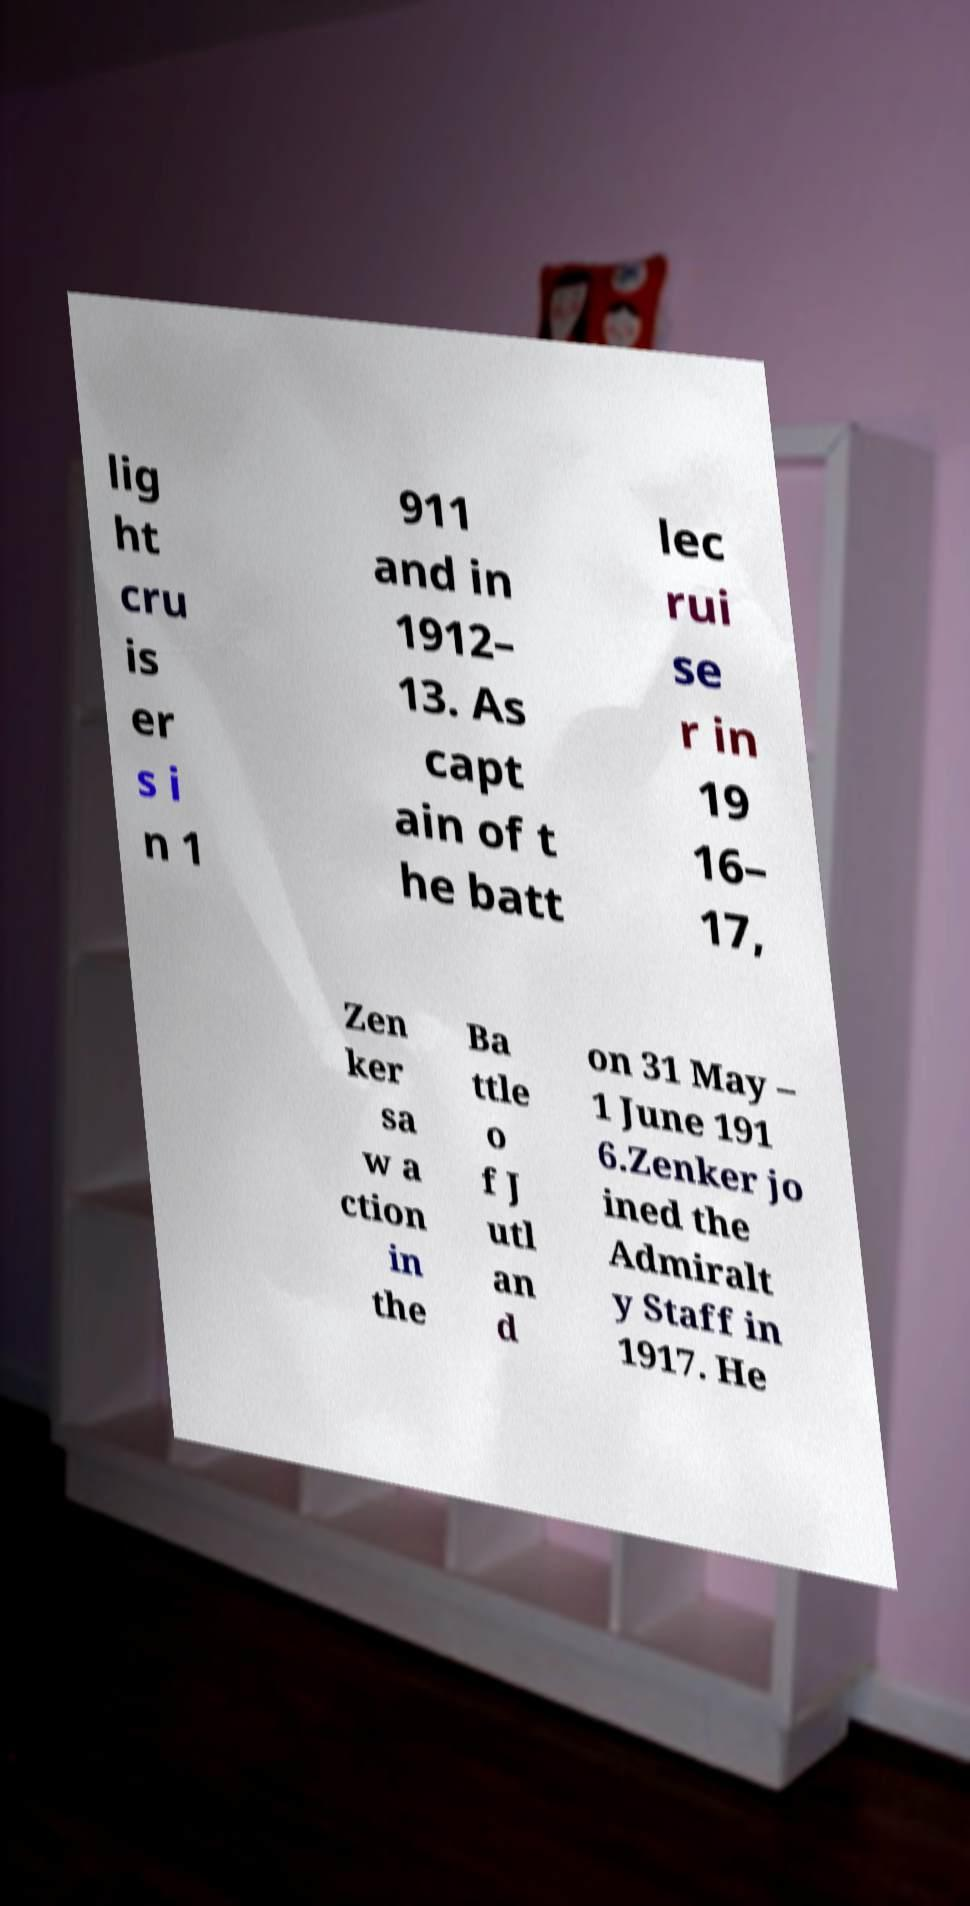Could you assist in decoding the text presented in this image and type it out clearly? lig ht cru is er s i n 1 911 and in 1912– 13. As capt ain of t he batt lec rui se r in 19 16– 17, Zen ker sa w a ction in the Ba ttle o f J utl an d on 31 May – 1 June 191 6.Zenker jo ined the Admiralt y Staff in 1917. He 